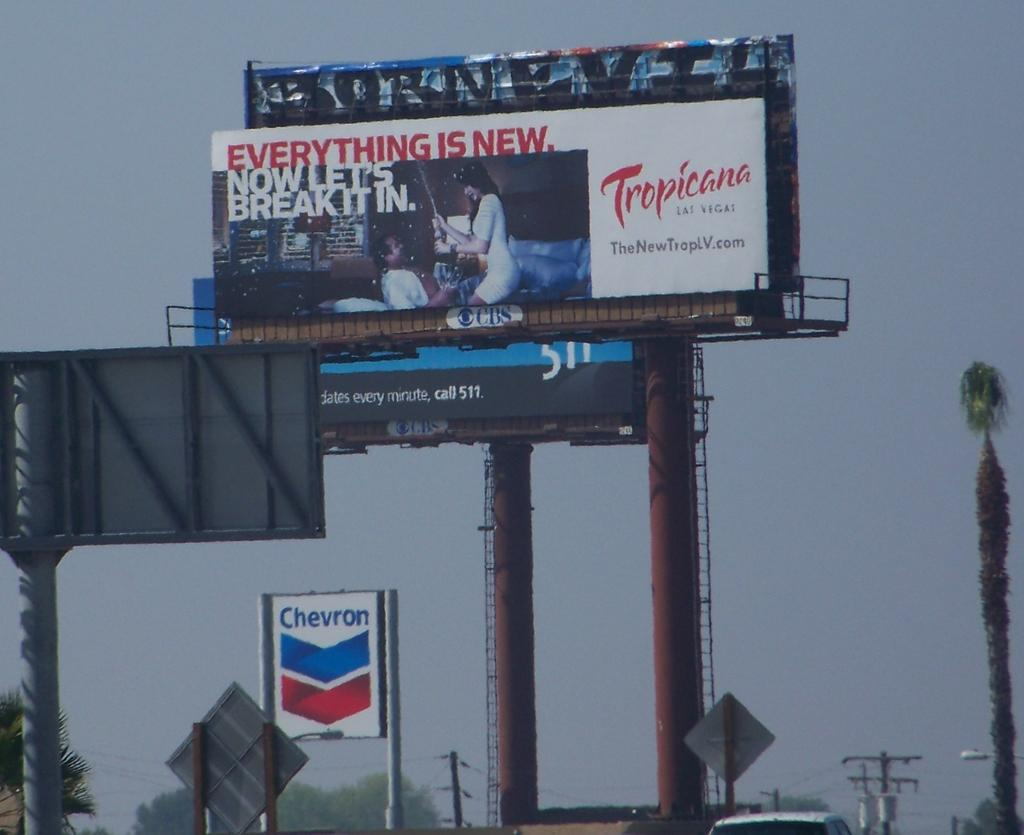<image>
Write a terse but informative summary of the picture. A billboard is posted for Tropicana in Las Vegas. 